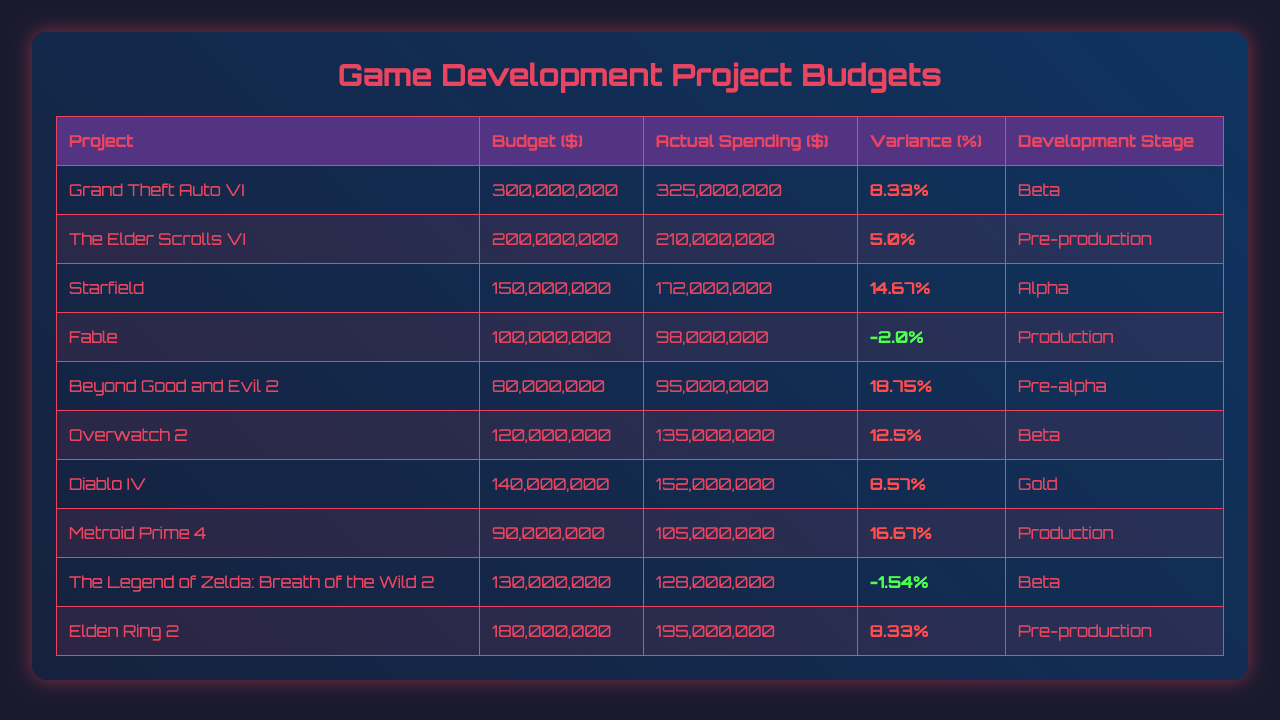What is the budget for "Elden Ring 2"? The budget for "Elden Ring 2" is listed in the table under the budget column for that project. It shows a value of 180,000,000.
Answer: 180000000 Which project had the highest actual spending? The table lists all ongoing projects with their actual spending. By reviewing the actual spending values, "Grand Theft Auto VI" has the highest actual spending of 325,000,000.
Answer: Grand Theft Auto VI How many projects are currently over budget? To find the number of projects over budget, we check the variance percentage for each project. If the variance is greater than zero, the project is over budget. There are 7 projects with positive variance percentages.
Answer: 7 What is the variance percentage for "Starfield"? The variance percentage for "Starfield" is found in the table next to the actual spending for that project. It shows a value of 14.67%.
Answer: 14.67% What is the average budget of all projects? To find the average budget, we sum all the budgets and divide by the number of projects. The total budget is 1,440,000,000 for 10 projects, making the average budget 144,000,000.
Answer: 144000000 Is "Fable" under budget? We determine if "Fable" is under budget by checking its variance percentage. Since it is -2.00%, it is under budget.
Answer: Yes What is the combined actual spending of the projects in beta development stage? We look for projects in the beta stage and sum their actual spending, which includes "Grand Theft Auto VI" (325,000,000), "Overwatch 2" (135,000,000), and "Metroid Prime 4" (105,000,000), totalling 565,000,000.
Answer: 565000000 What is the difference between the budget and actual spending for "Beyond Good and Evil 2"? To find the difference, we subtract the budget from actual spending. The budget is 80,000,000 and the actual spending is 95,000,000, leading to a difference of 15,000,000.
Answer: 15000000 How many projects are in the production stage, and what is their average budget? We first identify projects in the production stage: "Fable" and "Diablo IV". The budget for both is 100,000,000 and 140,000,000 respectively. The total is 240,000,000 for 2 projects, resulting in an average of 120,000,000.
Answer: 120000000 What is the overall variance percentage across all projects? To find the overall variance percentage, we calculate the sum of all variance percentages and divide by the number of projects. The total variance percentage is 70.00% for 10 projects, giving an average variance percentage of 7.00%.
Answer: 7.00% 